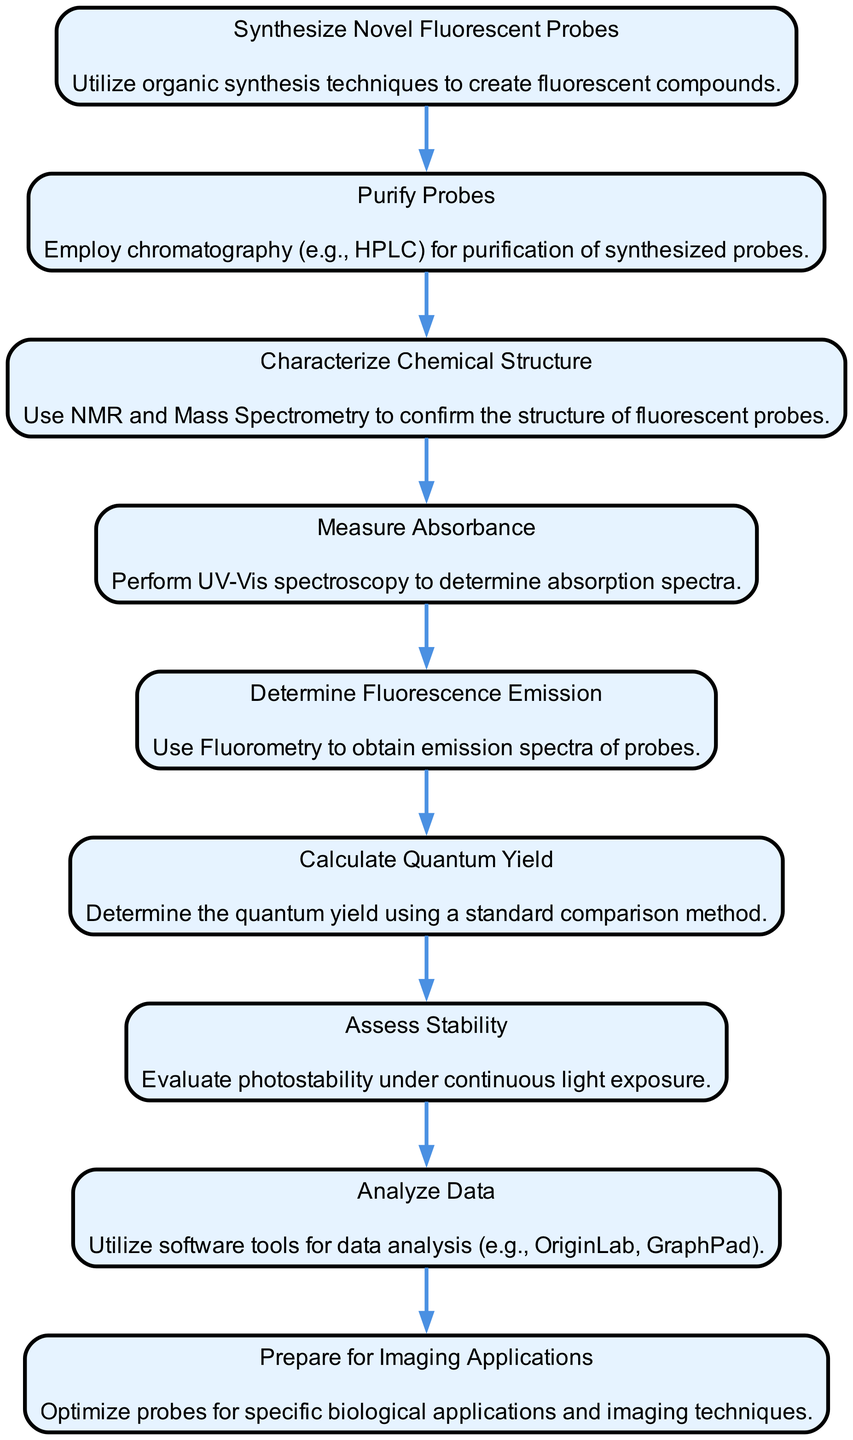What is the first step in the workflow? The first step listed in the workflow diagram is "Synthesize Novel Fluorescent Probes". This is indicated by the top node in the flow chart.
Answer: Synthesize Novel Fluorescent Probes How many total processes are indicated in the diagram? By counting the nodes in the flow chart, there are a total of 9 distinct processes represented.
Answer: 9 What technique is used for purification of probes? In the flow chart, the purification process mentions the use of "chromatography (e.g., HPLC)". This can be found in the node detailing the purification step.
Answer: chromatography (e.g., HPLC) What analysis technique is used to determine the chemical structure of the probes? The node representing the characterization of chemical structure specifies using "NMR and Mass Spectrometry", which are common analytical techniques for this purpose.
Answer: NMR and Mass Spectrometry What is the last process before preparing for imaging applications? The last process indicated just before “Prepare for Imaging Applications” is “Assess Stability”. This indicates that stability assessment is crucial before application preparation.
Answer: Assess Stability Which step involves the use of software tools? The step specifically mentioning the use of software tools for data analysis is “Analyze Data”. This part of the workflow emphasizes the analytical aspect using computational tools.
Answer: Analyze Data What is the significance of calculating the quantum yield in this workflow? The workflow indicates that calculating quantum yield provides quantitative insights into the efficiency of fluorescence, which can be critical for applications in imaging.
Answer: Efficiency of fluorescence What does the process of measuring absorbance involve? The step outlining measuring absorbance states "Perform UV-Vis spectroscopy", which specifies the technique and the nature of the measurement.
Answer: Perform UV-Vis spectroscopy Which technique is employed to evaluate photostability? The node dedicated to stability indicates the evaluation of "photostability under continuous light exposure", highlighting the conditions for assessing fluorescence stability.
Answer: photostability under continuous light exposure 